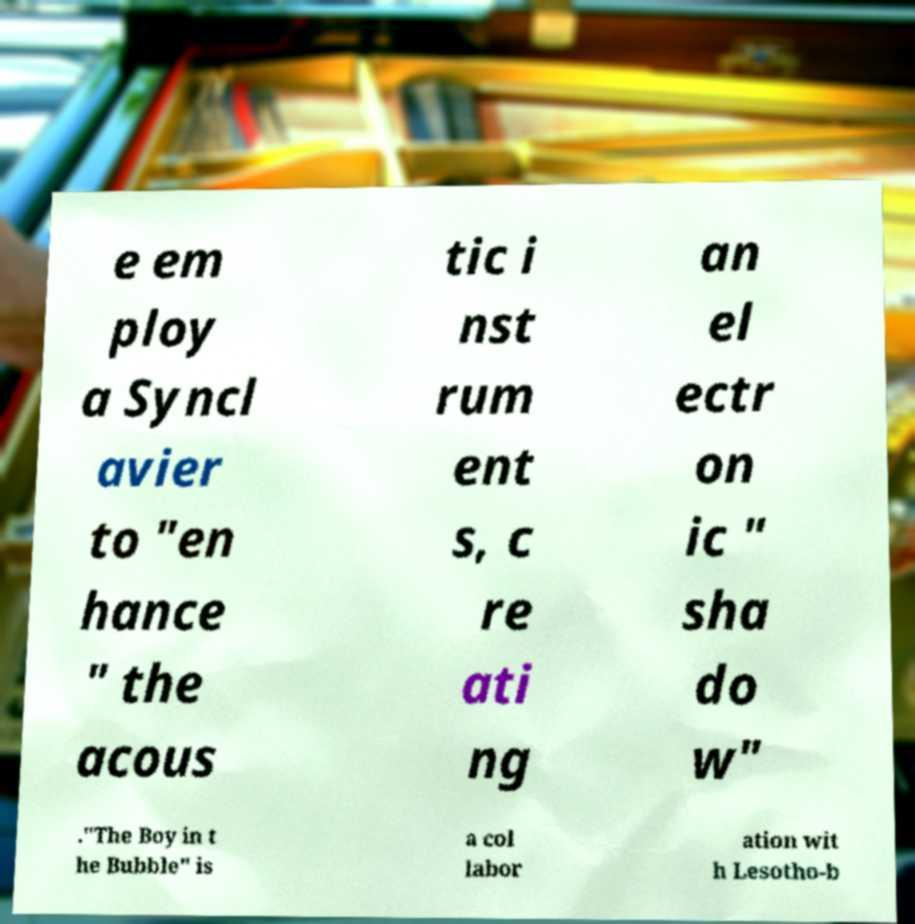For documentation purposes, I need the text within this image transcribed. Could you provide that? e em ploy a Syncl avier to "en hance " the acous tic i nst rum ent s, c re ati ng an el ectr on ic " sha do w" ."The Boy in t he Bubble" is a col labor ation wit h Lesotho-b 